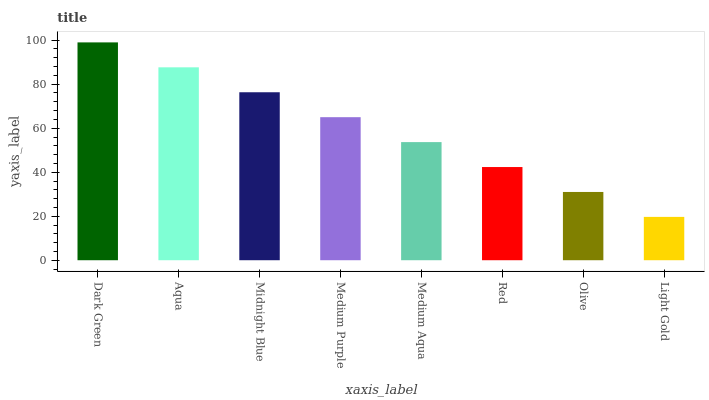Is Light Gold the minimum?
Answer yes or no. Yes. Is Dark Green the maximum?
Answer yes or no. Yes. Is Aqua the minimum?
Answer yes or no. No. Is Aqua the maximum?
Answer yes or no. No. Is Dark Green greater than Aqua?
Answer yes or no. Yes. Is Aqua less than Dark Green?
Answer yes or no. Yes. Is Aqua greater than Dark Green?
Answer yes or no. No. Is Dark Green less than Aqua?
Answer yes or no. No. Is Medium Purple the high median?
Answer yes or no. Yes. Is Medium Aqua the low median?
Answer yes or no. Yes. Is Light Gold the high median?
Answer yes or no. No. Is Olive the low median?
Answer yes or no. No. 